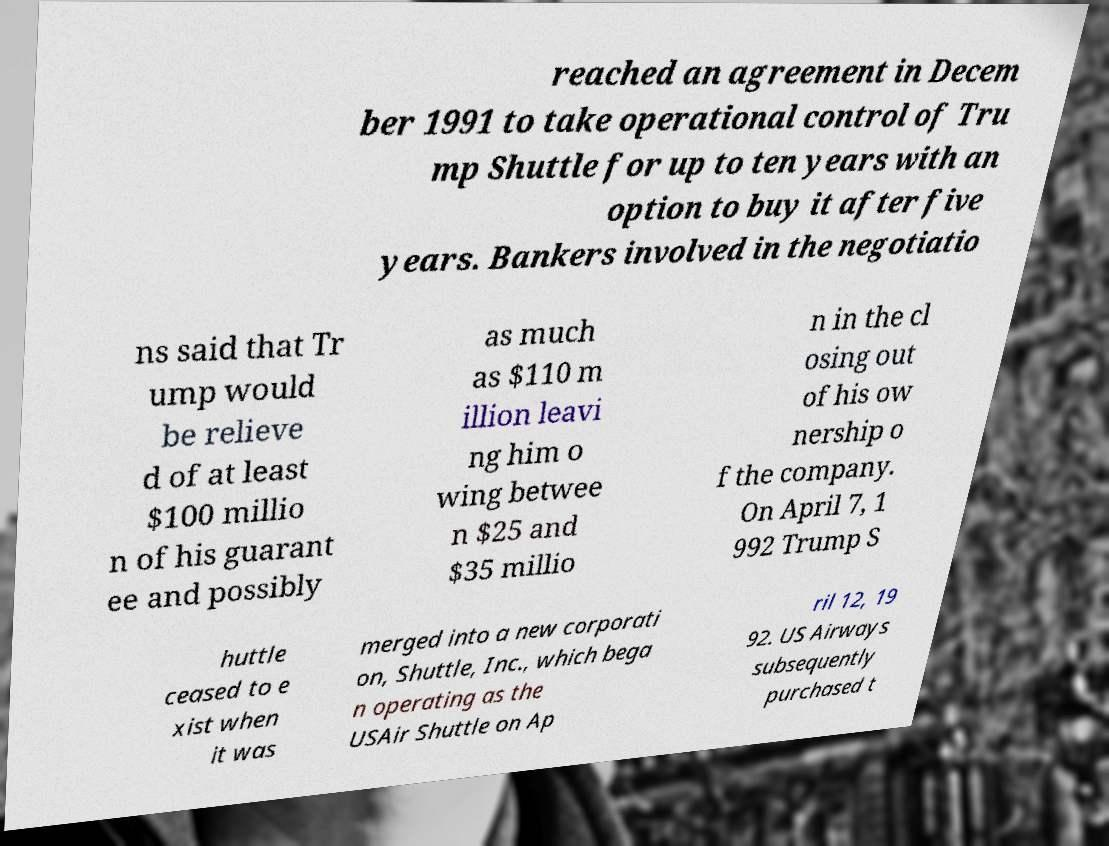What messages or text are displayed in this image? I need them in a readable, typed format. reached an agreement in Decem ber 1991 to take operational control of Tru mp Shuttle for up to ten years with an option to buy it after five years. Bankers involved in the negotiatio ns said that Tr ump would be relieve d of at least $100 millio n of his guarant ee and possibly as much as $110 m illion leavi ng him o wing betwee n $25 and $35 millio n in the cl osing out of his ow nership o f the company. On April 7, 1 992 Trump S huttle ceased to e xist when it was merged into a new corporati on, Shuttle, Inc., which bega n operating as the USAir Shuttle on Ap ril 12, 19 92. US Airways subsequently purchased t 